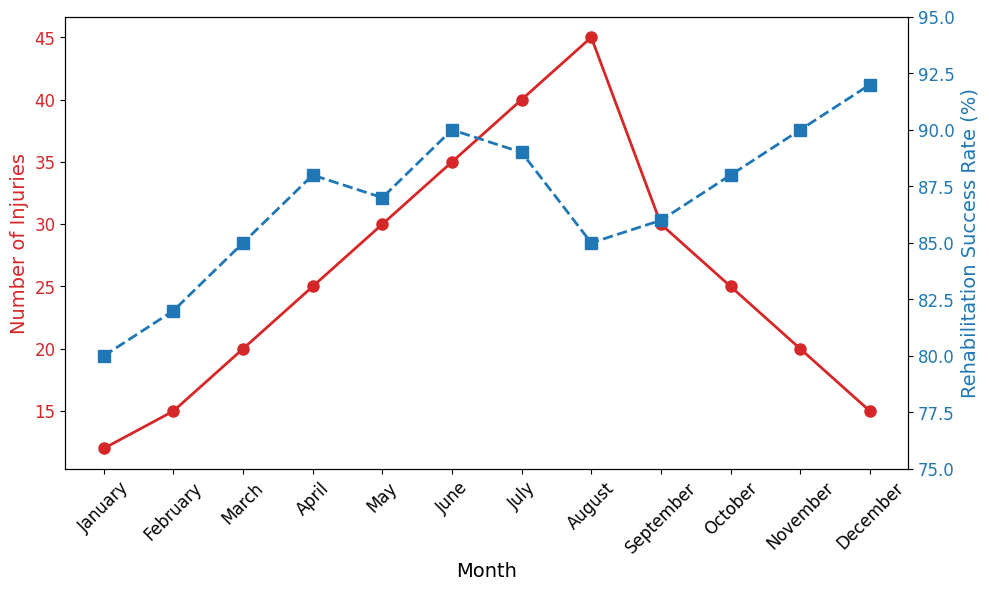Which month has the highest number of injuries? Look at the plot of the red line representing the number of injuries and find the highest point. The highest point is in August, with 45 injuries.
Answer: August Which month has the highest rehabilitation success rate? Refer to the blue line representing rehabilitation success rate and check the highest value point. December has the highest rehabilitation success rate of 92%.
Answer: December Is the rehabilitation success rate in July higher or lower than in June? Compare the values for July and June on the blue line. July has a success rate of 89%, while June has a rate of 90%, so July is lower.
Answer: Lower What's the difference in the number of injuries between January and July? Differences between the values for July and January on the red line. In July, there are 40 injuries, and in January, there are 12 injuries. The difference is 40 - 12 = 28.
Answer: 28 What is the trend in the number of injuries from January to June? Observing the red line from January to June shows a continuous rise. Starting with 12 injuries in January and increasing each month until it reaches 35 in June.
Answer: Increasing How does the rehabilitation success rate vary from March to September? Follow the blue line from March to September. It starts at 85% in March, rises to 90% in June, and slightly fluctuates between 85% and 89% up to September.
Answer: Rises and fluctuates What is the average number of injuries reported from April to August? Sum the number of injuries for April, May, June, July, and August: (25 + 30 + 35 + 40 + 45) = 175, then divide by 5: 175 / 5 = 35.
Answer: 35 How does the number of injuries in February compare to November? Compare the red line at February and November. February shows 15 injuries, and November also shows 20 injuries.
Answer: Lower Are there any months where the number of injuries is the same? Observe the red line for any horizontal alignment of points. Both April and October have 25 injuries each.
Answer: April and October What is the trend in the rehabilitation success rate from May to November? Follow the blue line from May to November. It starts at 87% in May, increases to 90% in June, fluctuates slightly, and reaches 90% again in November.
Answer: Fluctuating with an overall increase 